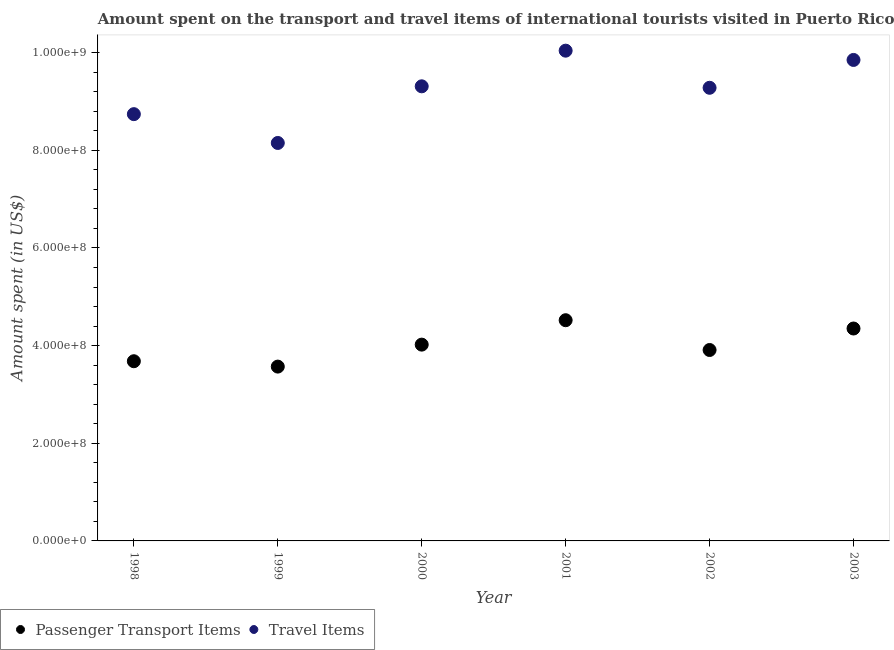Is the number of dotlines equal to the number of legend labels?
Your answer should be very brief. Yes. What is the amount spent in travel items in 1999?
Provide a succinct answer. 8.15e+08. Across all years, what is the maximum amount spent in travel items?
Your response must be concise. 1.00e+09. Across all years, what is the minimum amount spent in travel items?
Provide a succinct answer. 8.15e+08. What is the total amount spent in travel items in the graph?
Make the answer very short. 5.54e+09. What is the difference between the amount spent in travel items in 1999 and that in 2002?
Your answer should be very brief. -1.13e+08. What is the difference between the amount spent on passenger transport items in 2002 and the amount spent in travel items in 1998?
Provide a short and direct response. -4.83e+08. What is the average amount spent in travel items per year?
Your response must be concise. 9.23e+08. In the year 2000, what is the difference between the amount spent on passenger transport items and amount spent in travel items?
Offer a terse response. -5.29e+08. What is the ratio of the amount spent on passenger transport items in 1998 to that in 2002?
Your response must be concise. 0.94. What is the difference between the highest and the second highest amount spent on passenger transport items?
Ensure brevity in your answer.  1.70e+07. What is the difference between the highest and the lowest amount spent in travel items?
Your answer should be very brief. 1.89e+08. In how many years, is the amount spent on passenger transport items greater than the average amount spent on passenger transport items taken over all years?
Make the answer very short. 3. Is the sum of the amount spent in travel items in 1998 and 2000 greater than the maximum amount spent on passenger transport items across all years?
Provide a succinct answer. Yes. Is the amount spent in travel items strictly less than the amount spent on passenger transport items over the years?
Provide a succinct answer. No. How many years are there in the graph?
Your answer should be compact. 6. What is the difference between two consecutive major ticks on the Y-axis?
Your answer should be compact. 2.00e+08. Are the values on the major ticks of Y-axis written in scientific E-notation?
Provide a short and direct response. Yes. Where does the legend appear in the graph?
Give a very brief answer. Bottom left. How are the legend labels stacked?
Your answer should be very brief. Horizontal. What is the title of the graph?
Ensure brevity in your answer.  Amount spent on the transport and travel items of international tourists visited in Puerto Rico. Does "By country of asylum" appear as one of the legend labels in the graph?
Your answer should be compact. No. What is the label or title of the Y-axis?
Provide a short and direct response. Amount spent (in US$). What is the Amount spent (in US$) in Passenger Transport Items in 1998?
Provide a short and direct response. 3.68e+08. What is the Amount spent (in US$) in Travel Items in 1998?
Your response must be concise. 8.74e+08. What is the Amount spent (in US$) of Passenger Transport Items in 1999?
Offer a very short reply. 3.57e+08. What is the Amount spent (in US$) of Travel Items in 1999?
Keep it short and to the point. 8.15e+08. What is the Amount spent (in US$) in Passenger Transport Items in 2000?
Ensure brevity in your answer.  4.02e+08. What is the Amount spent (in US$) of Travel Items in 2000?
Give a very brief answer. 9.31e+08. What is the Amount spent (in US$) in Passenger Transport Items in 2001?
Your response must be concise. 4.52e+08. What is the Amount spent (in US$) of Travel Items in 2001?
Your response must be concise. 1.00e+09. What is the Amount spent (in US$) in Passenger Transport Items in 2002?
Give a very brief answer. 3.91e+08. What is the Amount spent (in US$) of Travel Items in 2002?
Your answer should be very brief. 9.28e+08. What is the Amount spent (in US$) of Passenger Transport Items in 2003?
Your response must be concise. 4.35e+08. What is the Amount spent (in US$) of Travel Items in 2003?
Give a very brief answer. 9.85e+08. Across all years, what is the maximum Amount spent (in US$) in Passenger Transport Items?
Ensure brevity in your answer.  4.52e+08. Across all years, what is the maximum Amount spent (in US$) of Travel Items?
Offer a terse response. 1.00e+09. Across all years, what is the minimum Amount spent (in US$) of Passenger Transport Items?
Offer a terse response. 3.57e+08. Across all years, what is the minimum Amount spent (in US$) of Travel Items?
Your response must be concise. 8.15e+08. What is the total Amount spent (in US$) of Passenger Transport Items in the graph?
Keep it short and to the point. 2.40e+09. What is the total Amount spent (in US$) of Travel Items in the graph?
Offer a terse response. 5.54e+09. What is the difference between the Amount spent (in US$) in Passenger Transport Items in 1998 and that in 1999?
Offer a very short reply. 1.10e+07. What is the difference between the Amount spent (in US$) of Travel Items in 1998 and that in 1999?
Give a very brief answer. 5.90e+07. What is the difference between the Amount spent (in US$) in Passenger Transport Items in 1998 and that in 2000?
Provide a short and direct response. -3.40e+07. What is the difference between the Amount spent (in US$) in Travel Items in 1998 and that in 2000?
Give a very brief answer. -5.70e+07. What is the difference between the Amount spent (in US$) in Passenger Transport Items in 1998 and that in 2001?
Offer a very short reply. -8.40e+07. What is the difference between the Amount spent (in US$) in Travel Items in 1998 and that in 2001?
Keep it short and to the point. -1.30e+08. What is the difference between the Amount spent (in US$) of Passenger Transport Items in 1998 and that in 2002?
Ensure brevity in your answer.  -2.30e+07. What is the difference between the Amount spent (in US$) in Travel Items in 1998 and that in 2002?
Your answer should be compact. -5.40e+07. What is the difference between the Amount spent (in US$) in Passenger Transport Items in 1998 and that in 2003?
Give a very brief answer. -6.70e+07. What is the difference between the Amount spent (in US$) of Travel Items in 1998 and that in 2003?
Provide a succinct answer. -1.11e+08. What is the difference between the Amount spent (in US$) in Passenger Transport Items in 1999 and that in 2000?
Provide a short and direct response. -4.50e+07. What is the difference between the Amount spent (in US$) in Travel Items in 1999 and that in 2000?
Your answer should be compact. -1.16e+08. What is the difference between the Amount spent (in US$) in Passenger Transport Items in 1999 and that in 2001?
Provide a succinct answer. -9.50e+07. What is the difference between the Amount spent (in US$) of Travel Items in 1999 and that in 2001?
Your answer should be compact. -1.89e+08. What is the difference between the Amount spent (in US$) in Passenger Transport Items in 1999 and that in 2002?
Keep it short and to the point. -3.40e+07. What is the difference between the Amount spent (in US$) in Travel Items in 1999 and that in 2002?
Keep it short and to the point. -1.13e+08. What is the difference between the Amount spent (in US$) of Passenger Transport Items in 1999 and that in 2003?
Your response must be concise. -7.80e+07. What is the difference between the Amount spent (in US$) in Travel Items in 1999 and that in 2003?
Keep it short and to the point. -1.70e+08. What is the difference between the Amount spent (in US$) in Passenger Transport Items in 2000 and that in 2001?
Your answer should be very brief. -5.00e+07. What is the difference between the Amount spent (in US$) of Travel Items in 2000 and that in 2001?
Your response must be concise. -7.30e+07. What is the difference between the Amount spent (in US$) in Passenger Transport Items in 2000 and that in 2002?
Provide a succinct answer. 1.10e+07. What is the difference between the Amount spent (in US$) of Passenger Transport Items in 2000 and that in 2003?
Offer a terse response. -3.30e+07. What is the difference between the Amount spent (in US$) in Travel Items in 2000 and that in 2003?
Your response must be concise. -5.40e+07. What is the difference between the Amount spent (in US$) in Passenger Transport Items in 2001 and that in 2002?
Your response must be concise. 6.10e+07. What is the difference between the Amount spent (in US$) in Travel Items in 2001 and that in 2002?
Provide a short and direct response. 7.60e+07. What is the difference between the Amount spent (in US$) of Passenger Transport Items in 2001 and that in 2003?
Your answer should be very brief. 1.70e+07. What is the difference between the Amount spent (in US$) of Travel Items in 2001 and that in 2003?
Give a very brief answer. 1.90e+07. What is the difference between the Amount spent (in US$) of Passenger Transport Items in 2002 and that in 2003?
Ensure brevity in your answer.  -4.40e+07. What is the difference between the Amount spent (in US$) in Travel Items in 2002 and that in 2003?
Ensure brevity in your answer.  -5.70e+07. What is the difference between the Amount spent (in US$) in Passenger Transport Items in 1998 and the Amount spent (in US$) in Travel Items in 1999?
Provide a succinct answer. -4.47e+08. What is the difference between the Amount spent (in US$) in Passenger Transport Items in 1998 and the Amount spent (in US$) in Travel Items in 2000?
Keep it short and to the point. -5.63e+08. What is the difference between the Amount spent (in US$) in Passenger Transport Items in 1998 and the Amount spent (in US$) in Travel Items in 2001?
Your answer should be compact. -6.36e+08. What is the difference between the Amount spent (in US$) in Passenger Transport Items in 1998 and the Amount spent (in US$) in Travel Items in 2002?
Give a very brief answer. -5.60e+08. What is the difference between the Amount spent (in US$) in Passenger Transport Items in 1998 and the Amount spent (in US$) in Travel Items in 2003?
Offer a very short reply. -6.17e+08. What is the difference between the Amount spent (in US$) in Passenger Transport Items in 1999 and the Amount spent (in US$) in Travel Items in 2000?
Your answer should be very brief. -5.74e+08. What is the difference between the Amount spent (in US$) of Passenger Transport Items in 1999 and the Amount spent (in US$) of Travel Items in 2001?
Keep it short and to the point. -6.47e+08. What is the difference between the Amount spent (in US$) of Passenger Transport Items in 1999 and the Amount spent (in US$) of Travel Items in 2002?
Your answer should be very brief. -5.71e+08. What is the difference between the Amount spent (in US$) in Passenger Transport Items in 1999 and the Amount spent (in US$) in Travel Items in 2003?
Give a very brief answer. -6.28e+08. What is the difference between the Amount spent (in US$) in Passenger Transport Items in 2000 and the Amount spent (in US$) in Travel Items in 2001?
Offer a terse response. -6.02e+08. What is the difference between the Amount spent (in US$) in Passenger Transport Items in 2000 and the Amount spent (in US$) in Travel Items in 2002?
Your response must be concise. -5.26e+08. What is the difference between the Amount spent (in US$) of Passenger Transport Items in 2000 and the Amount spent (in US$) of Travel Items in 2003?
Keep it short and to the point. -5.83e+08. What is the difference between the Amount spent (in US$) of Passenger Transport Items in 2001 and the Amount spent (in US$) of Travel Items in 2002?
Offer a very short reply. -4.76e+08. What is the difference between the Amount spent (in US$) in Passenger Transport Items in 2001 and the Amount spent (in US$) in Travel Items in 2003?
Make the answer very short. -5.33e+08. What is the difference between the Amount spent (in US$) of Passenger Transport Items in 2002 and the Amount spent (in US$) of Travel Items in 2003?
Ensure brevity in your answer.  -5.94e+08. What is the average Amount spent (in US$) in Passenger Transport Items per year?
Your answer should be compact. 4.01e+08. What is the average Amount spent (in US$) in Travel Items per year?
Your answer should be compact. 9.23e+08. In the year 1998, what is the difference between the Amount spent (in US$) in Passenger Transport Items and Amount spent (in US$) in Travel Items?
Keep it short and to the point. -5.06e+08. In the year 1999, what is the difference between the Amount spent (in US$) of Passenger Transport Items and Amount spent (in US$) of Travel Items?
Offer a very short reply. -4.58e+08. In the year 2000, what is the difference between the Amount spent (in US$) in Passenger Transport Items and Amount spent (in US$) in Travel Items?
Make the answer very short. -5.29e+08. In the year 2001, what is the difference between the Amount spent (in US$) of Passenger Transport Items and Amount spent (in US$) of Travel Items?
Your answer should be very brief. -5.52e+08. In the year 2002, what is the difference between the Amount spent (in US$) of Passenger Transport Items and Amount spent (in US$) of Travel Items?
Your response must be concise. -5.37e+08. In the year 2003, what is the difference between the Amount spent (in US$) of Passenger Transport Items and Amount spent (in US$) of Travel Items?
Your response must be concise. -5.50e+08. What is the ratio of the Amount spent (in US$) in Passenger Transport Items in 1998 to that in 1999?
Your answer should be compact. 1.03. What is the ratio of the Amount spent (in US$) in Travel Items in 1998 to that in 1999?
Give a very brief answer. 1.07. What is the ratio of the Amount spent (in US$) in Passenger Transport Items in 1998 to that in 2000?
Provide a succinct answer. 0.92. What is the ratio of the Amount spent (in US$) of Travel Items in 1998 to that in 2000?
Keep it short and to the point. 0.94. What is the ratio of the Amount spent (in US$) of Passenger Transport Items in 1998 to that in 2001?
Ensure brevity in your answer.  0.81. What is the ratio of the Amount spent (in US$) in Travel Items in 1998 to that in 2001?
Provide a short and direct response. 0.87. What is the ratio of the Amount spent (in US$) in Travel Items in 1998 to that in 2002?
Give a very brief answer. 0.94. What is the ratio of the Amount spent (in US$) in Passenger Transport Items in 1998 to that in 2003?
Offer a very short reply. 0.85. What is the ratio of the Amount spent (in US$) in Travel Items in 1998 to that in 2003?
Give a very brief answer. 0.89. What is the ratio of the Amount spent (in US$) in Passenger Transport Items in 1999 to that in 2000?
Your answer should be compact. 0.89. What is the ratio of the Amount spent (in US$) of Travel Items in 1999 to that in 2000?
Your response must be concise. 0.88. What is the ratio of the Amount spent (in US$) of Passenger Transport Items in 1999 to that in 2001?
Keep it short and to the point. 0.79. What is the ratio of the Amount spent (in US$) of Travel Items in 1999 to that in 2001?
Ensure brevity in your answer.  0.81. What is the ratio of the Amount spent (in US$) in Travel Items in 1999 to that in 2002?
Your answer should be very brief. 0.88. What is the ratio of the Amount spent (in US$) of Passenger Transport Items in 1999 to that in 2003?
Keep it short and to the point. 0.82. What is the ratio of the Amount spent (in US$) in Travel Items in 1999 to that in 2003?
Your answer should be very brief. 0.83. What is the ratio of the Amount spent (in US$) of Passenger Transport Items in 2000 to that in 2001?
Ensure brevity in your answer.  0.89. What is the ratio of the Amount spent (in US$) of Travel Items in 2000 to that in 2001?
Offer a very short reply. 0.93. What is the ratio of the Amount spent (in US$) of Passenger Transport Items in 2000 to that in 2002?
Your answer should be compact. 1.03. What is the ratio of the Amount spent (in US$) in Travel Items in 2000 to that in 2002?
Offer a very short reply. 1. What is the ratio of the Amount spent (in US$) of Passenger Transport Items in 2000 to that in 2003?
Provide a short and direct response. 0.92. What is the ratio of the Amount spent (in US$) of Travel Items in 2000 to that in 2003?
Offer a very short reply. 0.95. What is the ratio of the Amount spent (in US$) in Passenger Transport Items in 2001 to that in 2002?
Give a very brief answer. 1.16. What is the ratio of the Amount spent (in US$) of Travel Items in 2001 to that in 2002?
Give a very brief answer. 1.08. What is the ratio of the Amount spent (in US$) of Passenger Transport Items in 2001 to that in 2003?
Give a very brief answer. 1.04. What is the ratio of the Amount spent (in US$) of Travel Items in 2001 to that in 2003?
Your answer should be compact. 1.02. What is the ratio of the Amount spent (in US$) of Passenger Transport Items in 2002 to that in 2003?
Your response must be concise. 0.9. What is the ratio of the Amount spent (in US$) in Travel Items in 2002 to that in 2003?
Your answer should be compact. 0.94. What is the difference between the highest and the second highest Amount spent (in US$) of Passenger Transport Items?
Provide a short and direct response. 1.70e+07. What is the difference between the highest and the second highest Amount spent (in US$) of Travel Items?
Offer a terse response. 1.90e+07. What is the difference between the highest and the lowest Amount spent (in US$) of Passenger Transport Items?
Keep it short and to the point. 9.50e+07. What is the difference between the highest and the lowest Amount spent (in US$) in Travel Items?
Make the answer very short. 1.89e+08. 